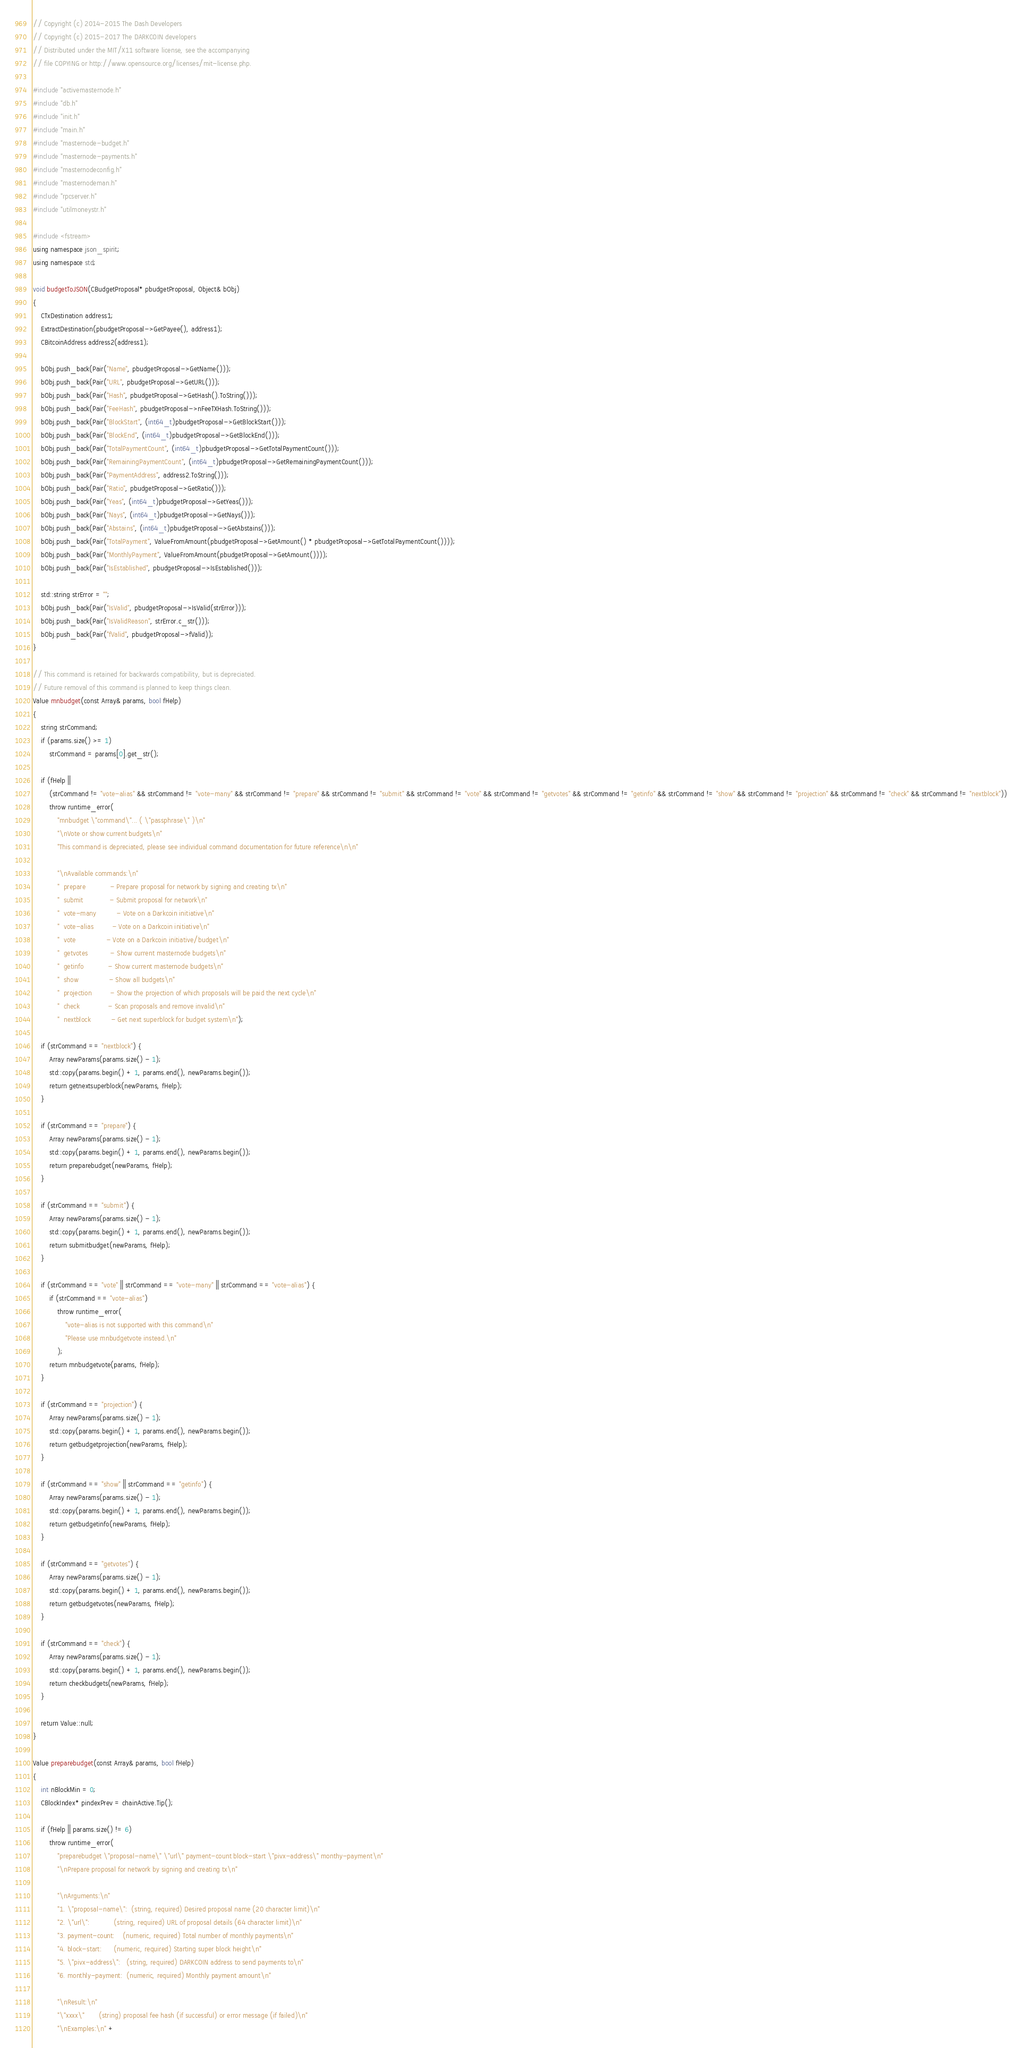<code> <loc_0><loc_0><loc_500><loc_500><_C++_>// Copyright (c) 2014-2015 The Dash Developers
// Copyright (c) 2015-2017 The DARKCOIN developers
// Distributed under the MIT/X11 software license, see the accompanying
// file COPYING or http://www.opensource.org/licenses/mit-license.php.

#include "activemasternode.h"
#include "db.h"
#include "init.h"
#include "main.h"
#include "masternode-budget.h"
#include "masternode-payments.h"
#include "masternodeconfig.h"
#include "masternodeman.h"
#include "rpcserver.h"
#include "utilmoneystr.h"

#include <fstream>
using namespace json_spirit;
using namespace std;

void budgetToJSON(CBudgetProposal* pbudgetProposal, Object& bObj)
{
    CTxDestination address1;
    ExtractDestination(pbudgetProposal->GetPayee(), address1);
    CBitcoinAddress address2(address1);

    bObj.push_back(Pair("Name", pbudgetProposal->GetName()));
    bObj.push_back(Pair("URL", pbudgetProposal->GetURL()));
    bObj.push_back(Pair("Hash", pbudgetProposal->GetHash().ToString()));
    bObj.push_back(Pair("FeeHash", pbudgetProposal->nFeeTXHash.ToString()));
    bObj.push_back(Pair("BlockStart", (int64_t)pbudgetProposal->GetBlockStart()));
    bObj.push_back(Pair("BlockEnd", (int64_t)pbudgetProposal->GetBlockEnd()));
    bObj.push_back(Pair("TotalPaymentCount", (int64_t)pbudgetProposal->GetTotalPaymentCount()));
    bObj.push_back(Pair("RemainingPaymentCount", (int64_t)pbudgetProposal->GetRemainingPaymentCount()));
    bObj.push_back(Pair("PaymentAddress", address2.ToString()));
    bObj.push_back(Pair("Ratio", pbudgetProposal->GetRatio()));
    bObj.push_back(Pair("Yeas", (int64_t)pbudgetProposal->GetYeas()));
    bObj.push_back(Pair("Nays", (int64_t)pbudgetProposal->GetNays()));
    bObj.push_back(Pair("Abstains", (int64_t)pbudgetProposal->GetAbstains()));
    bObj.push_back(Pair("TotalPayment", ValueFromAmount(pbudgetProposal->GetAmount() * pbudgetProposal->GetTotalPaymentCount())));
    bObj.push_back(Pair("MonthlyPayment", ValueFromAmount(pbudgetProposal->GetAmount())));
    bObj.push_back(Pair("IsEstablished", pbudgetProposal->IsEstablished()));

    std::string strError = "";
    bObj.push_back(Pair("IsValid", pbudgetProposal->IsValid(strError)));
    bObj.push_back(Pair("IsValidReason", strError.c_str()));
    bObj.push_back(Pair("fValid", pbudgetProposal->fValid));
}

// This command is retained for backwards compatibility, but is depreciated.
// Future removal of this command is planned to keep things clean.
Value mnbudget(const Array& params, bool fHelp)
{
    string strCommand;
    if (params.size() >= 1)
        strCommand = params[0].get_str();

    if (fHelp ||
        (strCommand != "vote-alias" && strCommand != "vote-many" && strCommand != "prepare" && strCommand != "submit" && strCommand != "vote" && strCommand != "getvotes" && strCommand != "getinfo" && strCommand != "show" && strCommand != "projection" && strCommand != "check" && strCommand != "nextblock"))
        throw runtime_error(
            "mnbudget \"command\"... ( \"passphrase\" )\n"
            "\nVote or show current budgets\n"
            "This command is depreciated, please see individual command documentation for future reference\n\n"

            "\nAvailable commands:\n"
            "  prepare            - Prepare proposal for network by signing and creating tx\n"
            "  submit             - Submit proposal for network\n"
            "  vote-many          - Vote on a Darkcoin initiative\n"
            "  vote-alias         - Vote on a Darkcoin initiative\n"
            "  vote               - Vote on a Darkcoin initiative/budget\n"
            "  getvotes           - Show current masternode budgets\n"
            "  getinfo            - Show current masternode budgets\n"
            "  show               - Show all budgets\n"
            "  projection         - Show the projection of which proposals will be paid the next cycle\n"
            "  check              - Scan proposals and remove invalid\n"
            "  nextblock          - Get next superblock for budget system\n");

    if (strCommand == "nextblock") {
        Array newParams(params.size() - 1);
        std::copy(params.begin() + 1, params.end(), newParams.begin());
        return getnextsuperblock(newParams, fHelp);
    }

    if (strCommand == "prepare") {
        Array newParams(params.size() - 1);
        std::copy(params.begin() + 1, params.end(), newParams.begin());
        return preparebudget(newParams, fHelp);
    }

    if (strCommand == "submit") {
        Array newParams(params.size() - 1);
        std::copy(params.begin() + 1, params.end(), newParams.begin());
        return submitbudget(newParams, fHelp);
    }

    if (strCommand == "vote" || strCommand == "vote-many" || strCommand == "vote-alias") {
        if (strCommand == "vote-alias")
            throw runtime_error(
                "vote-alias is not supported with this command\n"
                "Please use mnbudgetvote instead.\n"
            );
        return mnbudgetvote(params, fHelp);
    }

    if (strCommand == "projection") {
        Array newParams(params.size() - 1);
        std::copy(params.begin() + 1, params.end(), newParams.begin());
        return getbudgetprojection(newParams, fHelp);
    }

    if (strCommand == "show" || strCommand == "getinfo") {
        Array newParams(params.size() - 1);
        std::copy(params.begin() + 1, params.end(), newParams.begin());
        return getbudgetinfo(newParams, fHelp);
    }

    if (strCommand == "getvotes") {
        Array newParams(params.size() - 1);
        std::copy(params.begin() + 1, params.end(), newParams.begin());
        return getbudgetvotes(newParams, fHelp);
    }

    if (strCommand == "check") {
        Array newParams(params.size() - 1);
        std::copy(params.begin() + 1, params.end(), newParams.begin());
        return checkbudgets(newParams, fHelp);
    }

    return Value::null;
}

Value preparebudget(const Array& params, bool fHelp)
{
    int nBlockMin = 0;
    CBlockIndex* pindexPrev = chainActive.Tip();

    if (fHelp || params.size() != 6)
        throw runtime_error(
            "preparebudget \"proposal-name\" \"url\" payment-count block-start \"pivx-address\" monthy-payment\n"
            "\nPrepare proposal for network by signing and creating tx\n"

            "\nArguments:\n"
            "1. \"proposal-name\":  (string, required) Desired proposal name (20 character limit)\n"
            "2. \"url\":            (string, required) URL of proposal details (64 character limit)\n"
            "3. payment-count:    (numeric, required) Total number of monthly payments\n"
            "4. block-start:      (numeric, required) Starting super block height\n"
            "5. \"pivx-address\":   (string, required) DARKCOIN address to send payments to\n"
            "6. monthly-payment:  (numeric, required) Monthly payment amount\n"

            "\nResult:\n"
            "\"xxxx\"       (string) proposal fee hash (if successful) or error message (if failed)\n"
            "\nExamples:\n" +</code> 